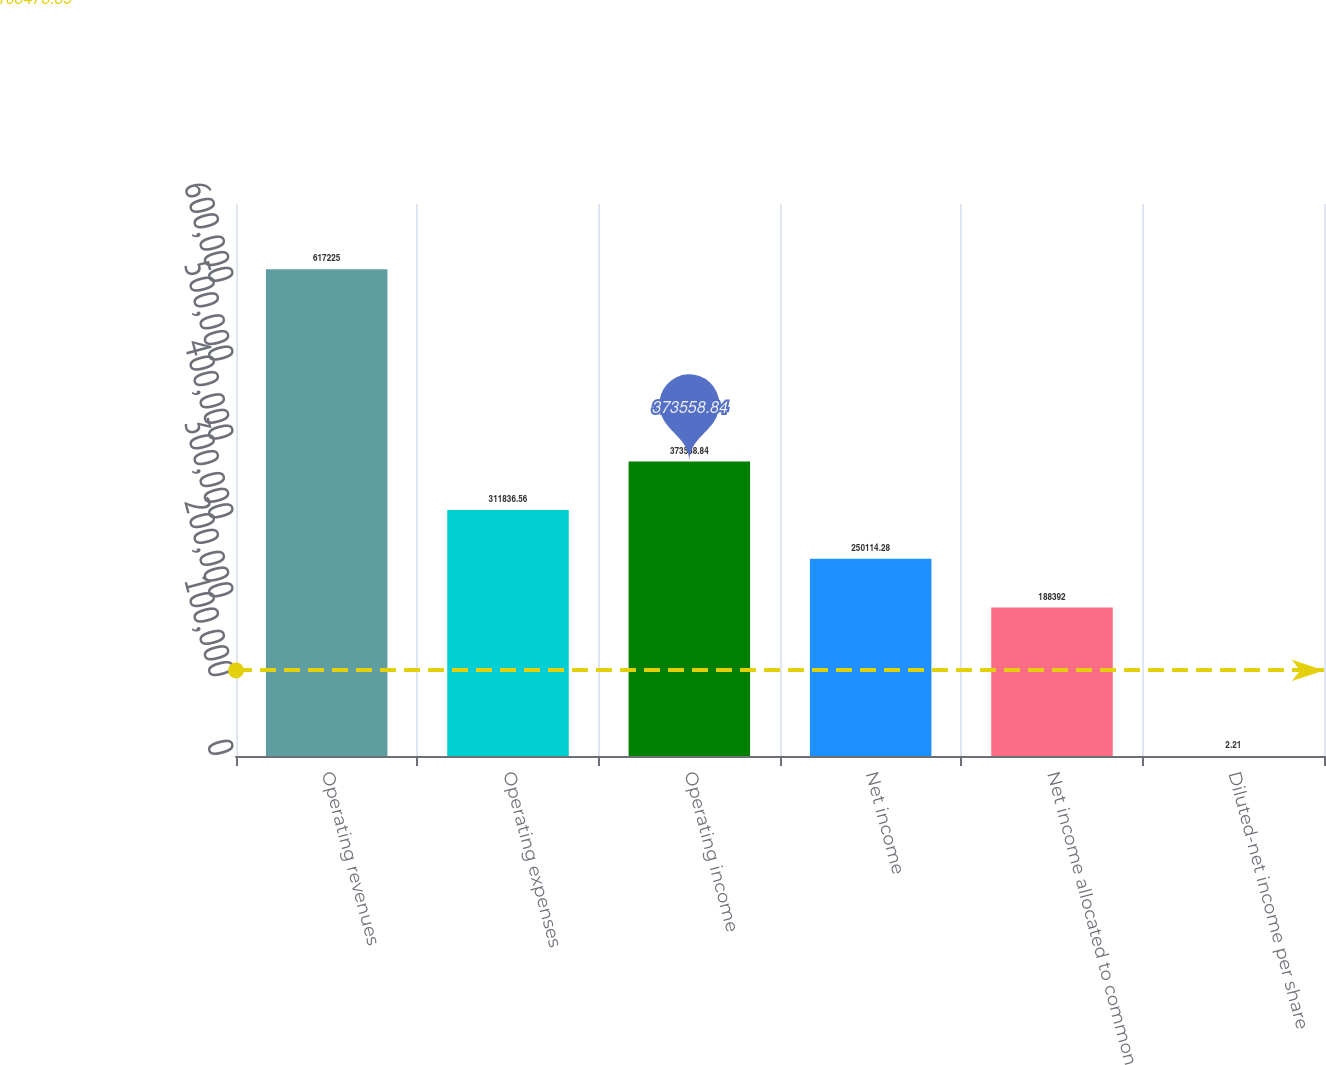Convert chart. <chart><loc_0><loc_0><loc_500><loc_500><bar_chart><fcel>Operating revenues<fcel>Operating expenses<fcel>Operating income<fcel>Net income<fcel>Net income allocated to common<fcel>Diluted-net income per share<nl><fcel>617225<fcel>311837<fcel>373559<fcel>250114<fcel>188392<fcel>2.21<nl></chart> 